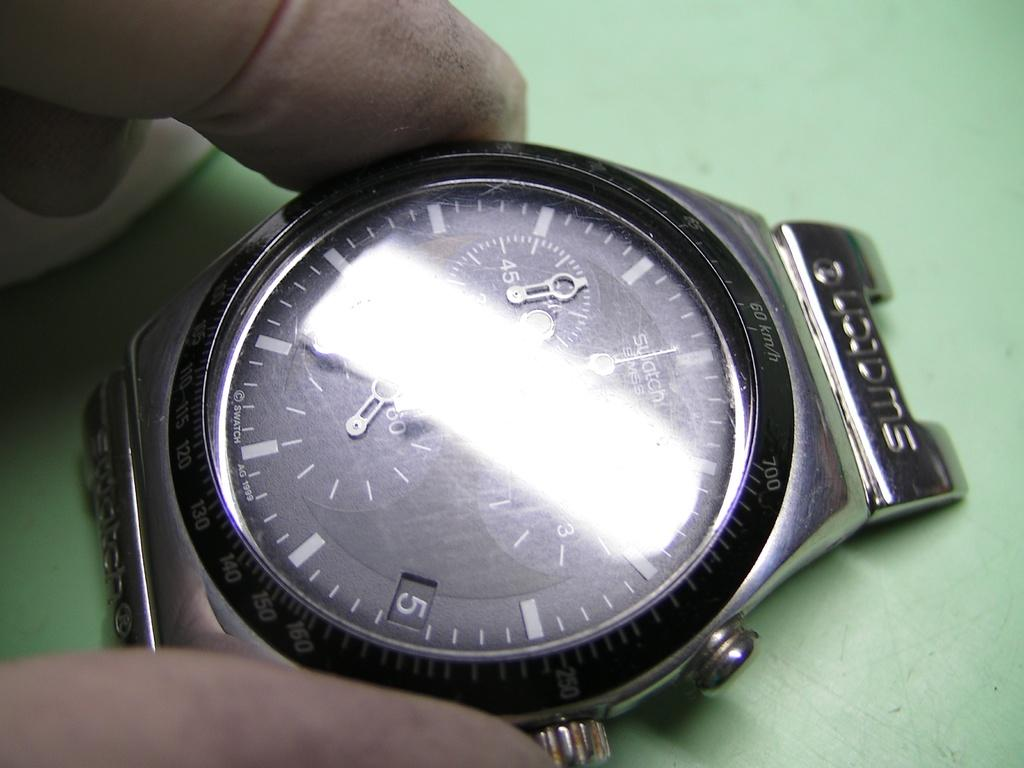<image>
Offer a succinct explanation of the picture presented. A strip of white blocks much of the face of a watch that shows the day of the month as 5. 